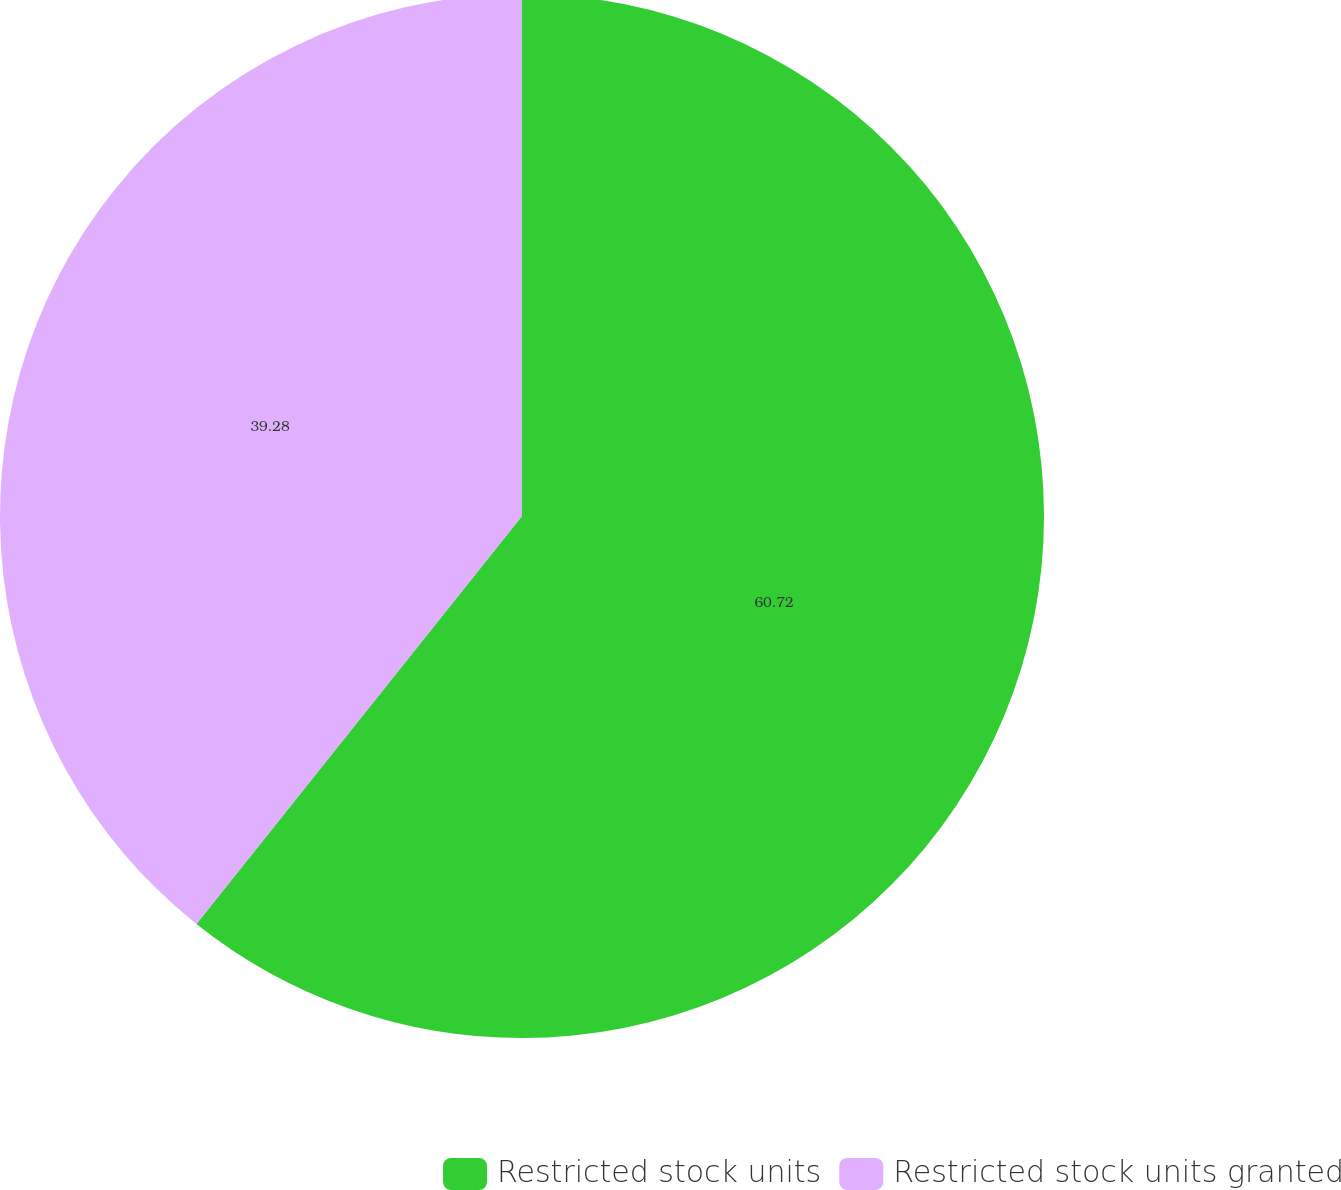<chart> <loc_0><loc_0><loc_500><loc_500><pie_chart><fcel>Restricted stock units<fcel>Restricted stock units granted<nl><fcel>60.72%<fcel>39.28%<nl></chart> 